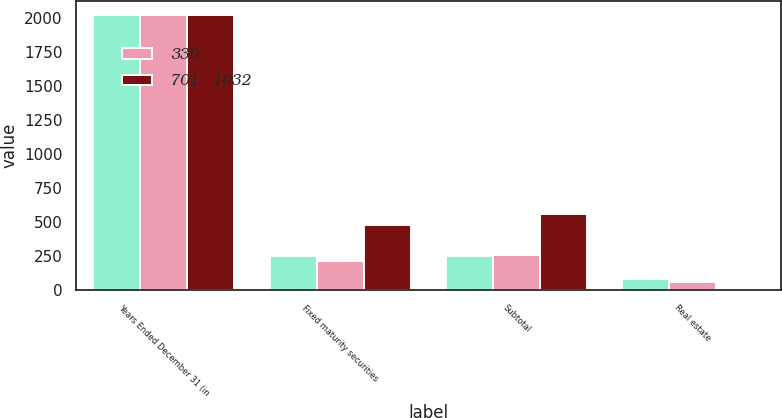Convert chart. <chart><loc_0><loc_0><loc_500><loc_500><stacked_bar_chart><ecel><fcel>Years Ended December 31 (in<fcel>Fixed maturity securities<fcel>Subtotal<fcel>Real estate<nl><fcel>nan<fcel>2018<fcel>251<fcel>251<fcel>79<nl><fcel>330<fcel>2017<fcel>216<fcel>260<fcel>61<nl><fcel>701   1032<fcel>2016<fcel>480<fcel>559<fcel>10<nl></chart> 